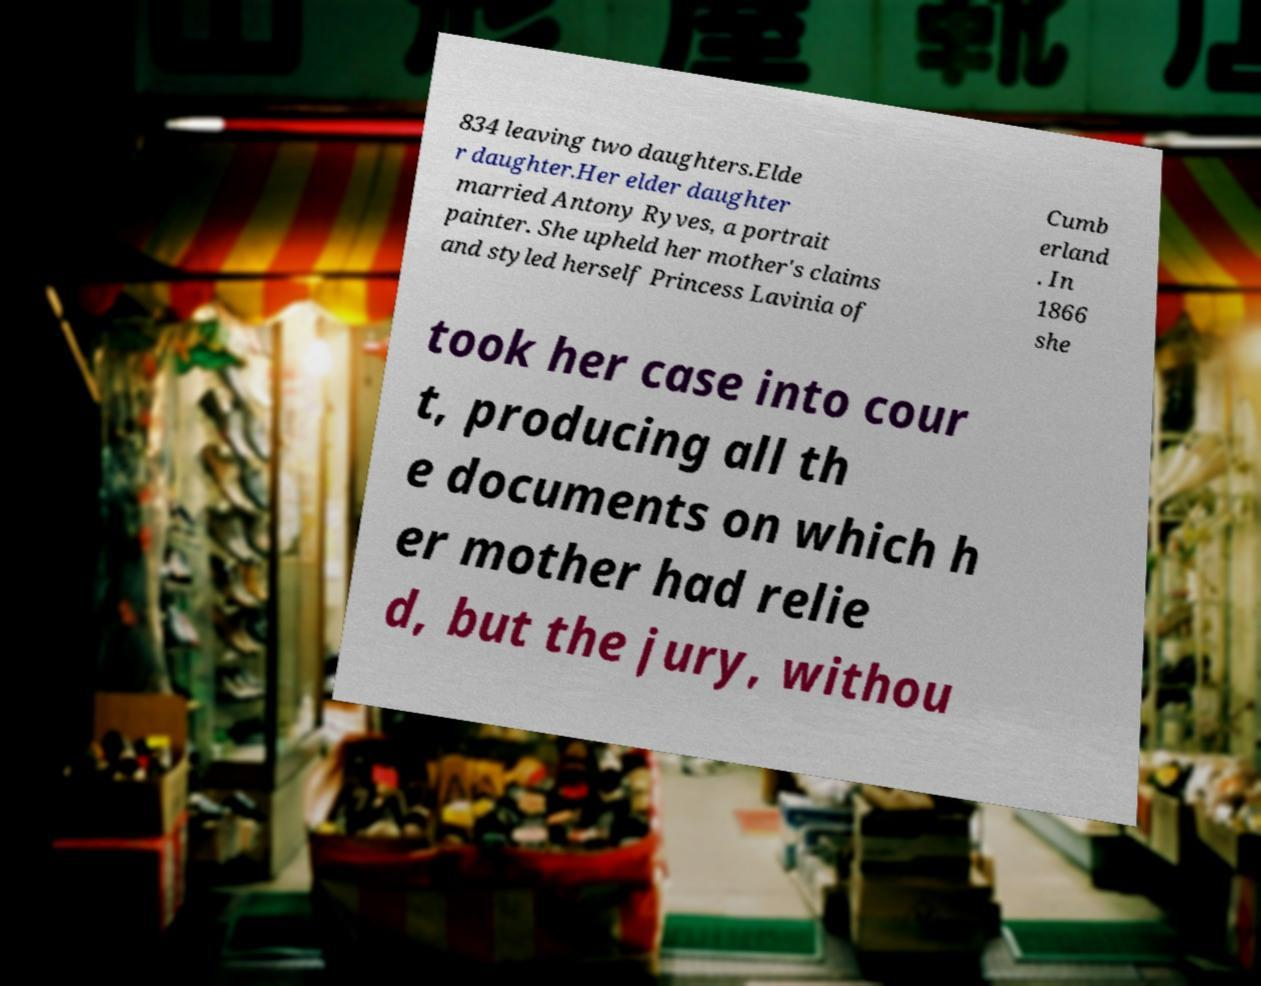I need the written content from this picture converted into text. Can you do that? 834 leaving two daughters.Elde r daughter.Her elder daughter married Antony Ryves, a portrait painter. She upheld her mother's claims and styled herself Princess Lavinia of Cumb erland . In 1866 she took her case into cour t, producing all th e documents on which h er mother had relie d, but the jury, withou 